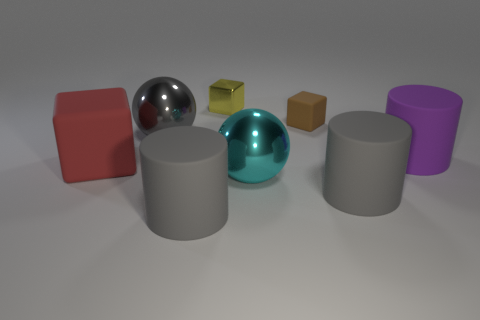Subtract all gray rubber cylinders. How many cylinders are left? 1 Add 2 big purple cylinders. How many objects exist? 10 Subtract all red cubes. How many gray cylinders are left? 2 Subtract all yellow blocks. How many blocks are left? 2 Subtract all cylinders. How many objects are left? 5 Subtract all red cylinders. Subtract all purple blocks. How many cylinders are left? 3 Subtract all yellow blocks. Subtract all cyan things. How many objects are left? 6 Add 7 purple objects. How many purple objects are left? 8 Add 8 tiny brown rubber objects. How many tiny brown rubber objects exist? 9 Subtract 0 blue spheres. How many objects are left? 8 